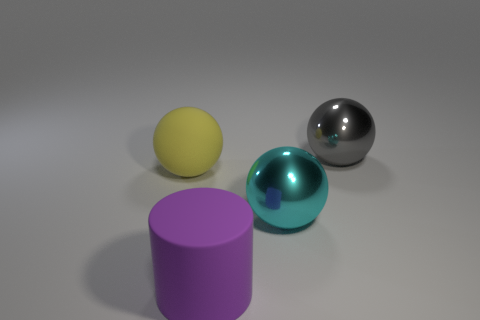What number of objects are either tiny green metal spheres or large shiny balls that are behind the yellow object?
Your answer should be compact. 1. Do the metal thing that is left of the gray thing and the yellow ball have the same size?
Your answer should be very brief. Yes. What number of other things are the same shape as the big yellow rubber object?
Your response must be concise. 2. How many gray objects are either large matte spheres or big matte cylinders?
Provide a short and direct response. 0. There is a large matte object that is in front of the cyan ball; is its color the same as the matte ball?
Give a very brief answer. No. There is another object that is the same material as the big gray thing; what is its shape?
Keep it short and to the point. Sphere. There is a big object that is both left of the cyan metal sphere and in front of the yellow sphere; what is its color?
Make the answer very short. Purple. There is a gray shiny sphere that is right of the matte thing on the left side of the big purple cylinder; how big is it?
Provide a succinct answer. Large. Are there any balls of the same color as the cylinder?
Your response must be concise. No. Is the number of cylinders in front of the large purple matte cylinder the same as the number of big yellow balls?
Provide a succinct answer. No. 